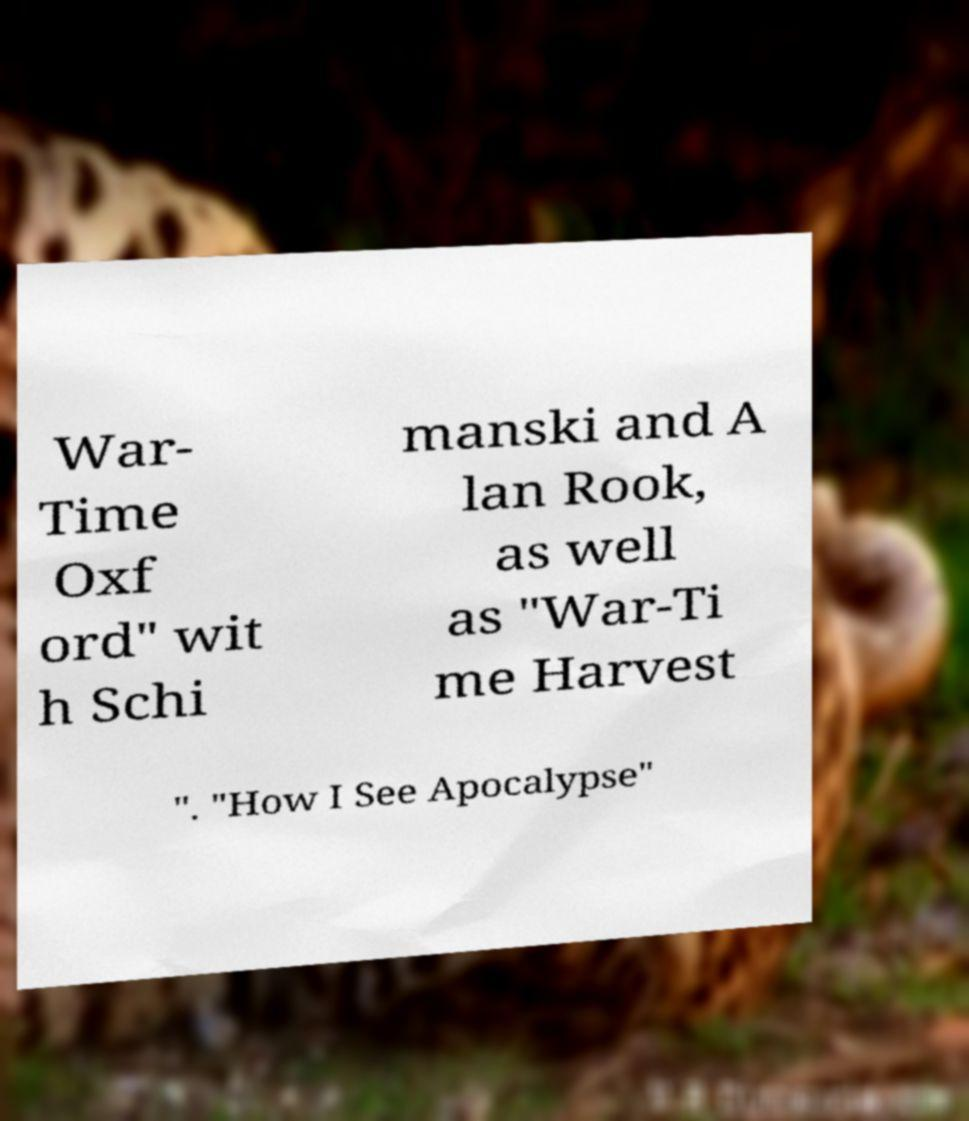Please identify and transcribe the text found in this image. War- Time Oxf ord" wit h Schi manski and A lan Rook, as well as "War-Ti me Harvest ". "How I See Apocalypse" 